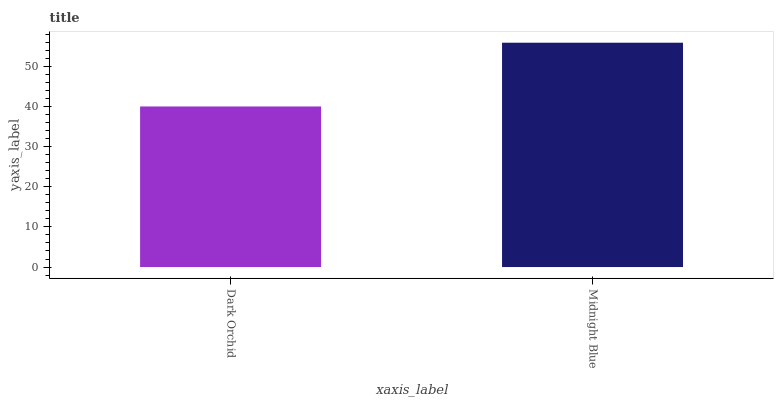Is Dark Orchid the minimum?
Answer yes or no. Yes. Is Midnight Blue the maximum?
Answer yes or no. Yes. Is Midnight Blue the minimum?
Answer yes or no. No. Is Midnight Blue greater than Dark Orchid?
Answer yes or no. Yes. Is Dark Orchid less than Midnight Blue?
Answer yes or no. Yes. Is Dark Orchid greater than Midnight Blue?
Answer yes or no. No. Is Midnight Blue less than Dark Orchid?
Answer yes or no. No. Is Midnight Blue the high median?
Answer yes or no. Yes. Is Dark Orchid the low median?
Answer yes or no. Yes. Is Dark Orchid the high median?
Answer yes or no. No. Is Midnight Blue the low median?
Answer yes or no. No. 